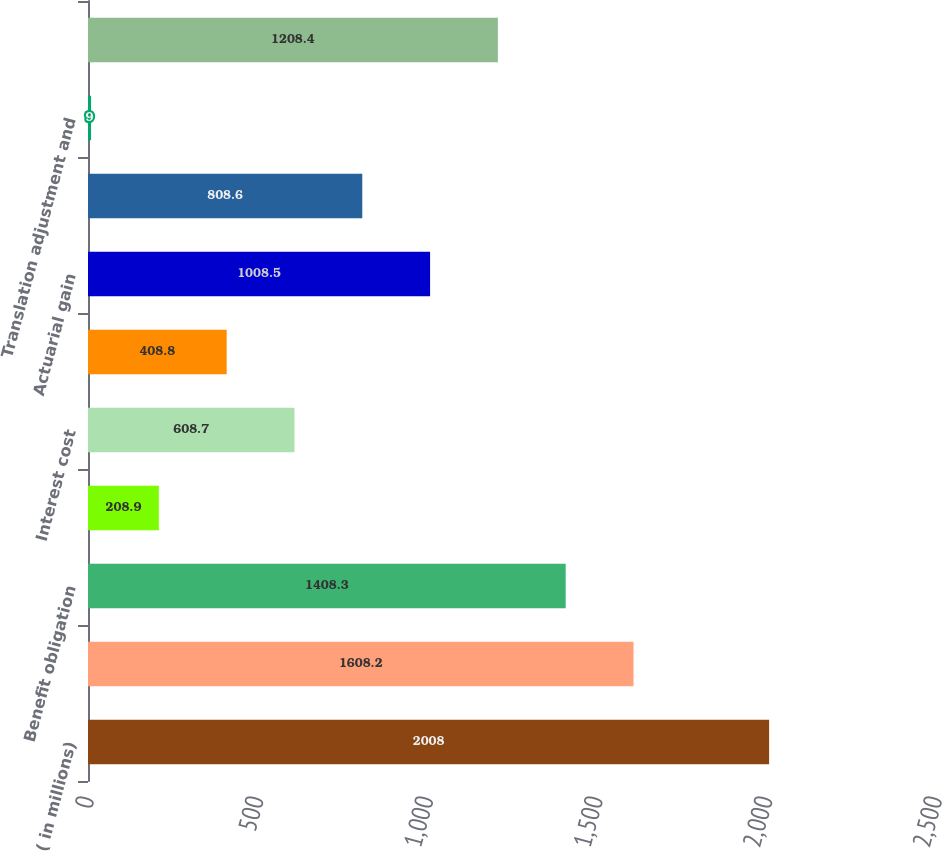<chart> <loc_0><loc_0><loc_500><loc_500><bar_chart><fcel>( in millions)<fcel>Benefit obligation beginning<fcel>Benefit obligation<fcel>Service cost<fcel>Interest cost<fcel>Participant contributions<fcel>Actuarial gain<fcel>Benefits paid (1)<fcel>Translation adjustment and<fcel>Benefit obligation end of year<nl><fcel>2008<fcel>1608.2<fcel>1408.3<fcel>208.9<fcel>608.7<fcel>408.8<fcel>1008.5<fcel>808.6<fcel>9<fcel>1208.4<nl></chart> 